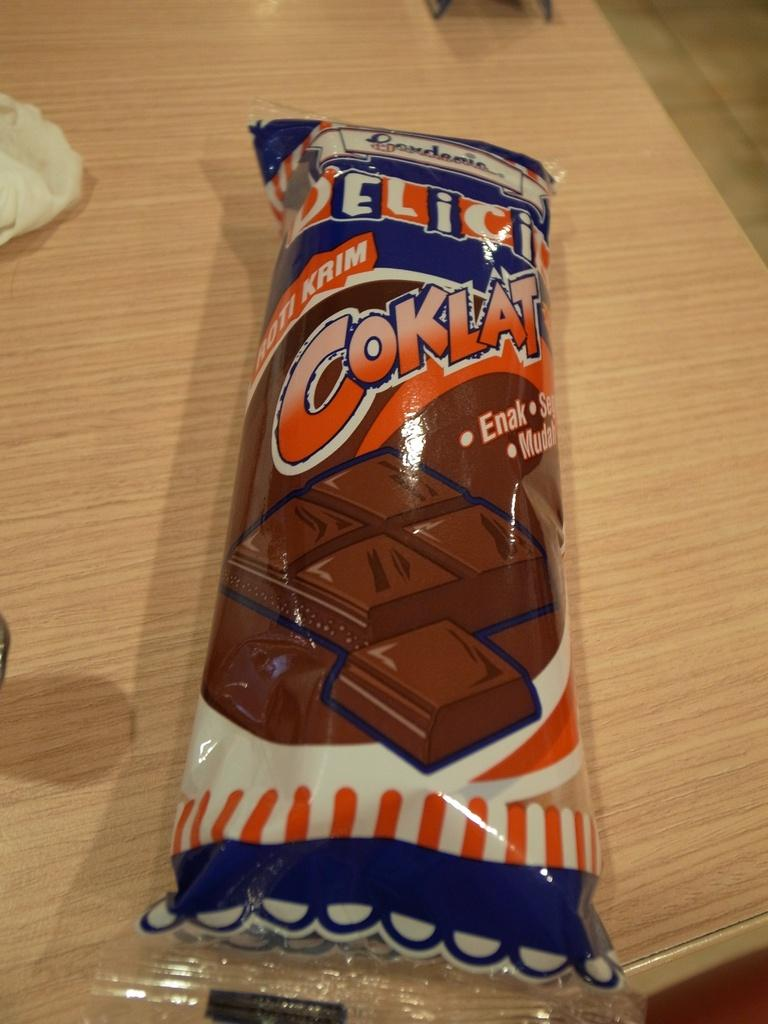What type of surface is visible in the image? There is a wooden surface in the image. What is placed on the wooden surface? There is a food packet on the wooden surface. What is depicted on the food packet? The food packet has a picture of chocolate cubes on it. What time of day is it in the image, based on the hour hand on a clock? There is no clock or hour hand present in the image, so it is not possible to determine the time of day. 